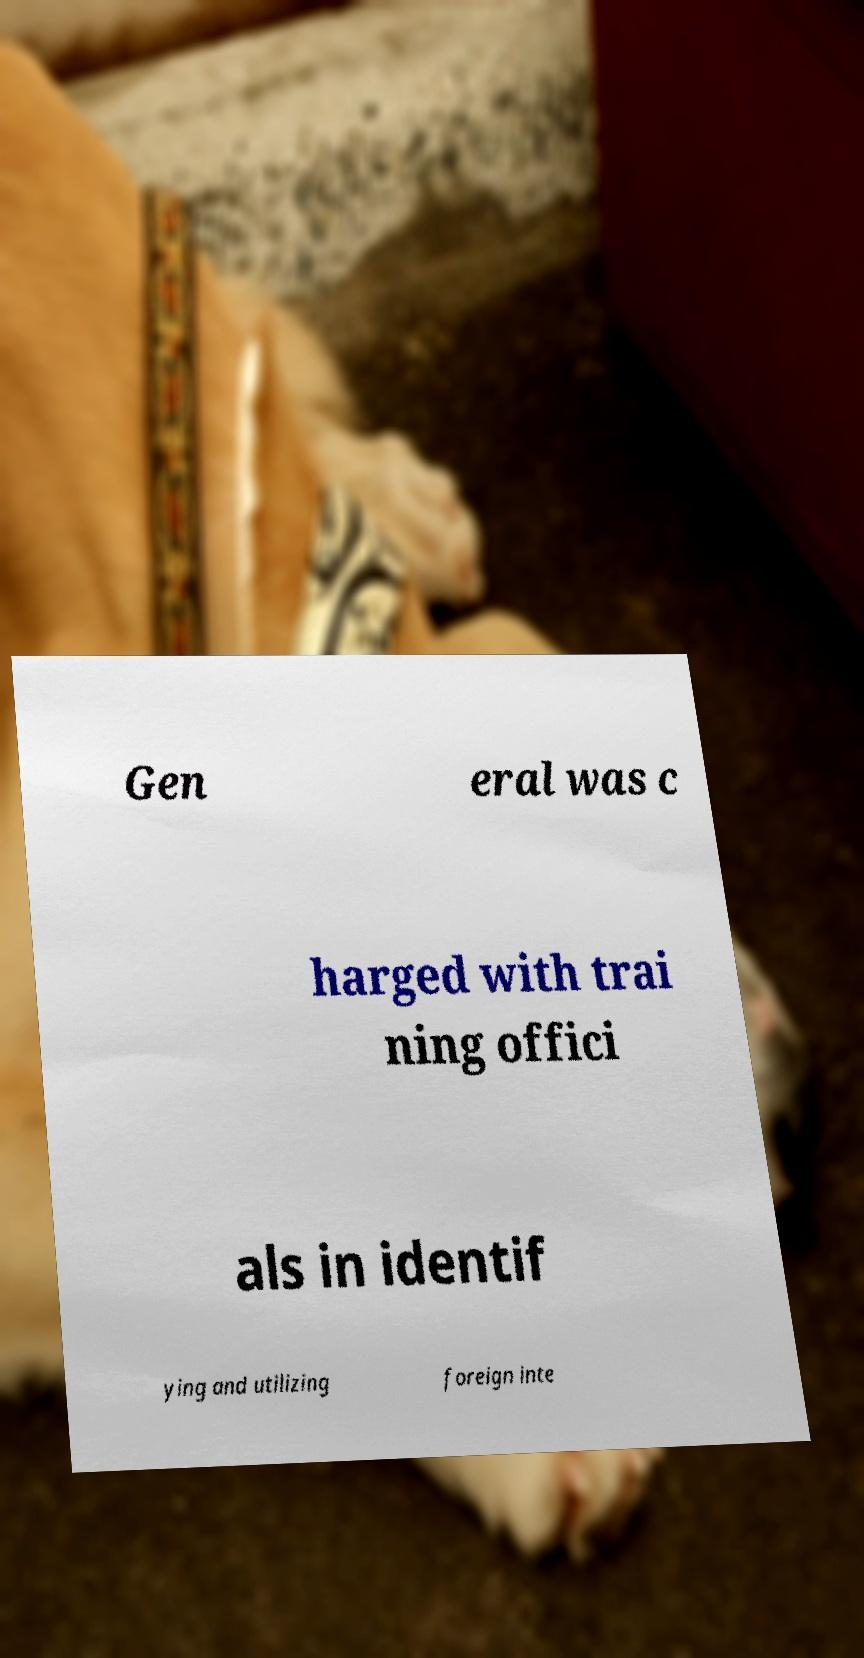There's text embedded in this image that I need extracted. Can you transcribe it verbatim? Gen eral was c harged with trai ning offici als in identif ying and utilizing foreign inte 